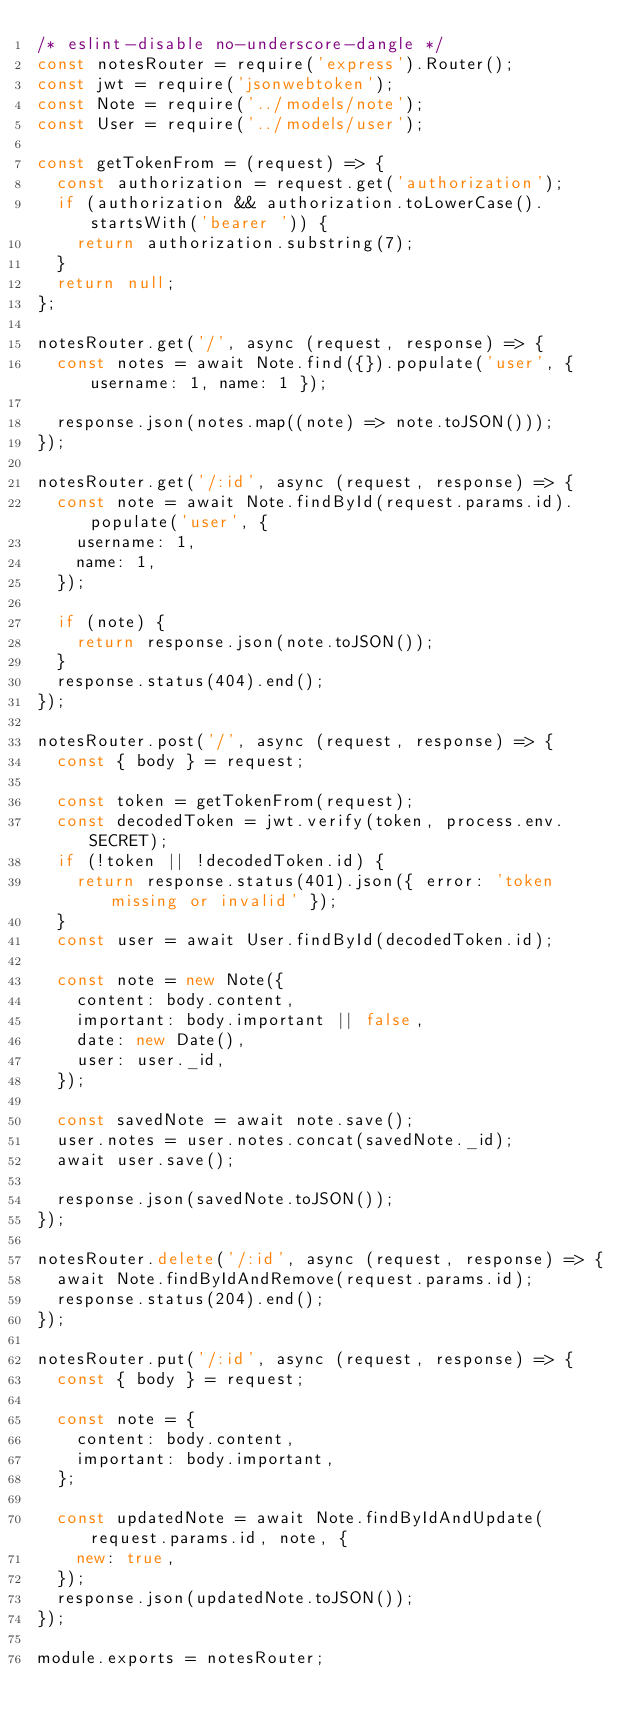<code> <loc_0><loc_0><loc_500><loc_500><_JavaScript_>/* eslint-disable no-underscore-dangle */
const notesRouter = require('express').Router();
const jwt = require('jsonwebtoken');
const Note = require('../models/note');
const User = require('../models/user');

const getTokenFrom = (request) => {
  const authorization = request.get('authorization');
  if (authorization && authorization.toLowerCase().startsWith('bearer ')) {
    return authorization.substring(7);
  }
  return null;
};

notesRouter.get('/', async (request, response) => {
  const notes = await Note.find({}).populate('user', { username: 1, name: 1 });

  response.json(notes.map((note) => note.toJSON()));
});

notesRouter.get('/:id', async (request, response) => {
  const note = await Note.findById(request.params.id).populate('user', {
    username: 1,
    name: 1,
  });

  if (note) {
    return response.json(note.toJSON());
  }
  response.status(404).end();
});

notesRouter.post('/', async (request, response) => {
  const { body } = request;

  const token = getTokenFrom(request);
  const decodedToken = jwt.verify(token, process.env.SECRET);
  if (!token || !decodedToken.id) {
    return response.status(401).json({ error: 'token missing or invalid' });
  }
  const user = await User.findById(decodedToken.id);

  const note = new Note({
    content: body.content,
    important: body.important || false,
    date: new Date(),
    user: user._id,
  });

  const savedNote = await note.save();
  user.notes = user.notes.concat(savedNote._id);
  await user.save();

  response.json(savedNote.toJSON());
});

notesRouter.delete('/:id', async (request, response) => {
  await Note.findByIdAndRemove(request.params.id);
  response.status(204).end();
});

notesRouter.put('/:id', async (request, response) => {
  const { body } = request;

  const note = {
    content: body.content,
    important: body.important,
  };

  const updatedNote = await Note.findByIdAndUpdate(request.params.id, note, {
    new: true,
  });
  response.json(updatedNote.toJSON());
});

module.exports = notesRouter;
</code> 